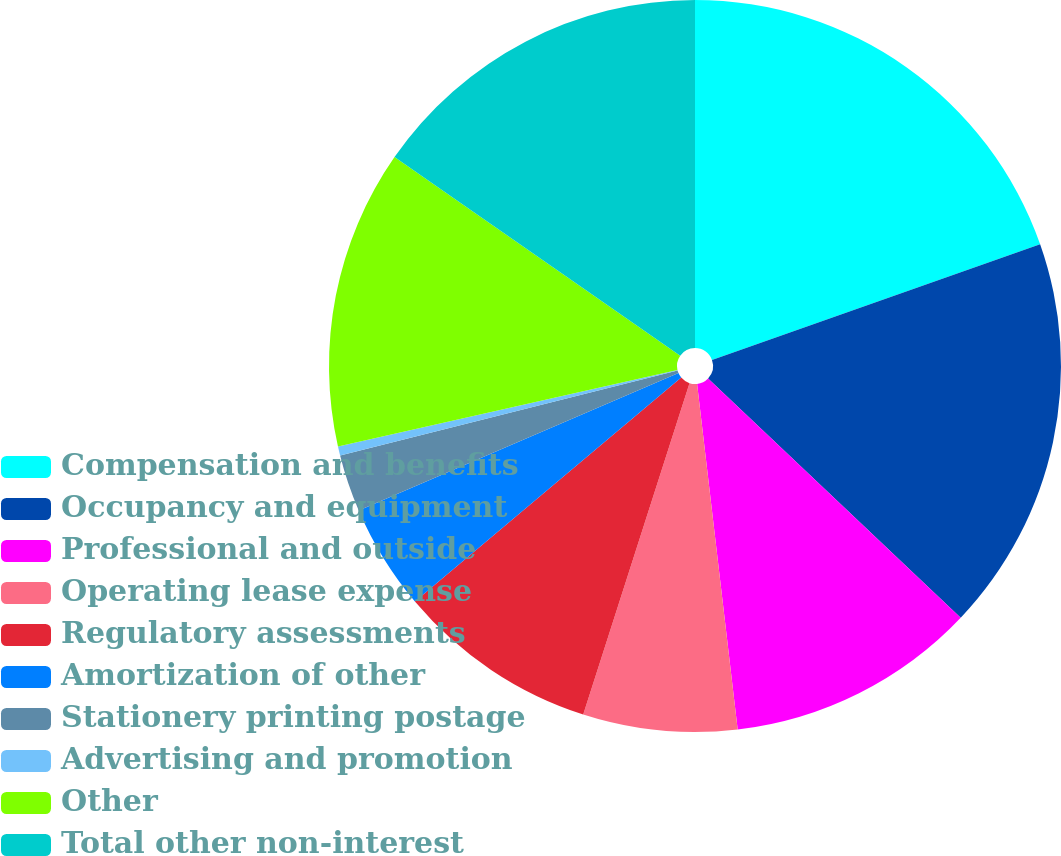<chart> <loc_0><loc_0><loc_500><loc_500><pie_chart><fcel>Compensation and benefits<fcel>Occupancy and equipment<fcel>Professional and outside<fcel>Operating lease expense<fcel>Regulatory assessments<fcel>Amortization of other<fcel>Stationery printing postage<fcel>Advertising and promotion<fcel>Other<fcel>Total other non-interest<nl><fcel>19.6%<fcel>17.47%<fcel>11.07%<fcel>6.8%<fcel>8.93%<fcel>4.67%<fcel>2.53%<fcel>0.4%<fcel>13.2%<fcel>15.33%<nl></chart> 